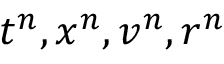Convert formula to latex. <formula><loc_0><loc_0><loc_500><loc_500>t ^ { n } , x ^ { n } , v ^ { n } , r ^ { n }</formula> 